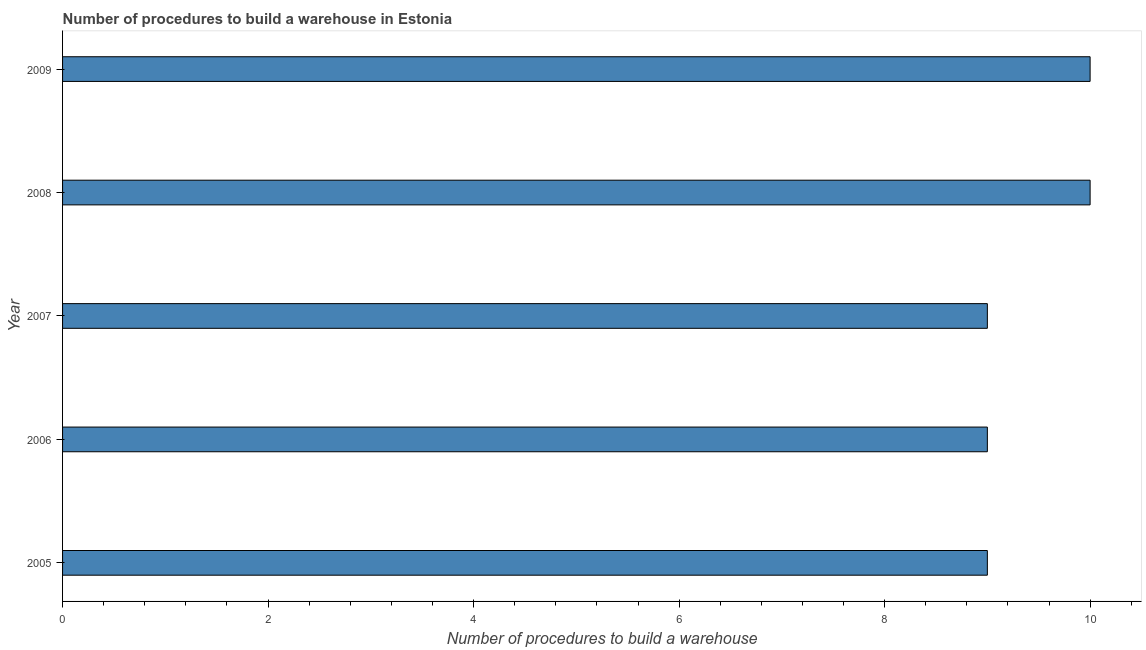Does the graph contain grids?
Keep it short and to the point. No. What is the title of the graph?
Offer a very short reply. Number of procedures to build a warehouse in Estonia. What is the label or title of the X-axis?
Keep it short and to the point. Number of procedures to build a warehouse. What is the label or title of the Y-axis?
Give a very brief answer. Year. Across all years, what is the maximum number of procedures to build a warehouse?
Make the answer very short. 10. In which year was the number of procedures to build a warehouse maximum?
Keep it short and to the point. 2008. What is the average number of procedures to build a warehouse per year?
Offer a very short reply. 9. What is the median number of procedures to build a warehouse?
Ensure brevity in your answer.  9. In how many years, is the number of procedures to build a warehouse greater than 5.6 ?
Your answer should be very brief. 5. Do a majority of the years between 2008 and 2007 (inclusive) have number of procedures to build a warehouse greater than 5.2 ?
Offer a terse response. No. Is the number of procedures to build a warehouse in 2007 less than that in 2009?
Make the answer very short. Yes. Is the difference between the number of procedures to build a warehouse in 2005 and 2008 greater than the difference between any two years?
Your answer should be compact. Yes. What is the difference between the highest and the second highest number of procedures to build a warehouse?
Your response must be concise. 0. What is the difference between the highest and the lowest number of procedures to build a warehouse?
Ensure brevity in your answer.  1. Are the values on the major ticks of X-axis written in scientific E-notation?
Provide a succinct answer. No. What is the Number of procedures to build a warehouse of 2009?
Make the answer very short. 10. What is the difference between the Number of procedures to build a warehouse in 2005 and 2006?
Your answer should be compact. 0. What is the difference between the Number of procedures to build a warehouse in 2005 and 2008?
Make the answer very short. -1. What is the difference between the Number of procedures to build a warehouse in 2006 and 2007?
Make the answer very short. 0. What is the difference between the Number of procedures to build a warehouse in 2006 and 2008?
Make the answer very short. -1. What is the difference between the Number of procedures to build a warehouse in 2007 and 2008?
Provide a succinct answer. -1. What is the difference between the Number of procedures to build a warehouse in 2007 and 2009?
Keep it short and to the point. -1. What is the ratio of the Number of procedures to build a warehouse in 2005 to that in 2007?
Keep it short and to the point. 1. What is the ratio of the Number of procedures to build a warehouse in 2006 to that in 2007?
Provide a short and direct response. 1. What is the ratio of the Number of procedures to build a warehouse in 2006 to that in 2009?
Make the answer very short. 0.9. 